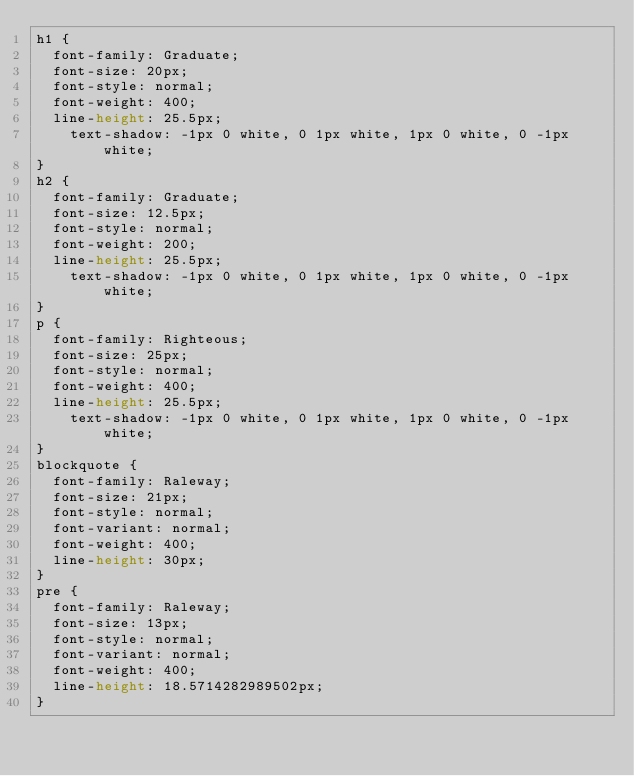<code> <loc_0><loc_0><loc_500><loc_500><_CSS_>h1 {
	font-family: Graduate;
	font-size: 20px;
	font-style: normal;
	font-weight: 400;
	line-height: 25.5px;
    text-shadow: -1px 0 white, 0 1px white, 1px 0 white, 0 -1px white;
}
h2 {
	font-family: Graduate;
	font-size: 12.5px;
	font-style: normal;
	font-weight: 200;
	line-height: 25.5px;
    text-shadow: -1px 0 white, 0 1px white, 1px 0 white, 0 -1px white;
}
p {
	font-family: Righteous;
	font-size: 25px;
	font-style: normal;
	font-weight: 400;
	line-height: 25.5px;
    text-shadow: -1px 0 white, 0 1px white, 1px 0 white, 0 -1px white;
}
blockquote {
	font-family: Raleway;
	font-size: 21px;
	font-style: normal;
	font-variant: normal;
	font-weight: 400;
	line-height: 30px;
}
pre {
	font-family: Raleway;
	font-size: 13px;
	font-style: normal;
	font-variant: normal;
	font-weight: 400;
	line-height: 18.5714282989502px;
}</code> 